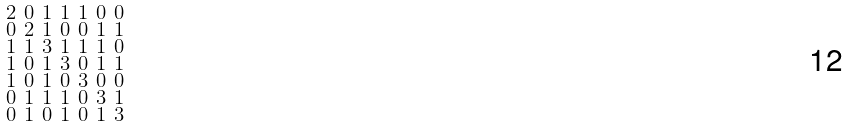<formula> <loc_0><loc_0><loc_500><loc_500>\begin{smallmatrix} 2 & 0 & 1 & 1 & 1 & 0 & 0 \\ 0 & 2 & 1 & 0 & 0 & 1 & 1 \\ 1 & 1 & 3 & 1 & 1 & 1 & 0 \\ 1 & 0 & 1 & 3 & 0 & 1 & 1 \\ 1 & 0 & 1 & 0 & 3 & 0 & 0 \\ 0 & 1 & 1 & 1 & 0 & 3 & 1 \\ 0 & 1 & 0 & 1 & 0 & 1 & 3 \end{smallmatrix}</formula> 